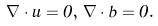Convert formula to latex. <formula><loc_0><loc_0><loc_500><loc_500>\nabla \cdot { u } = 0 , \, \nabla \cdot { b } = 0 .</formula> 